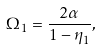Convert formula to latex. <formula><loc_0><loc_0><loc_500><loc_500>\Omega _ { 1 } = \frac { 2 \alpha } { 1 - \eta _ { 1 } } ,</formula> 